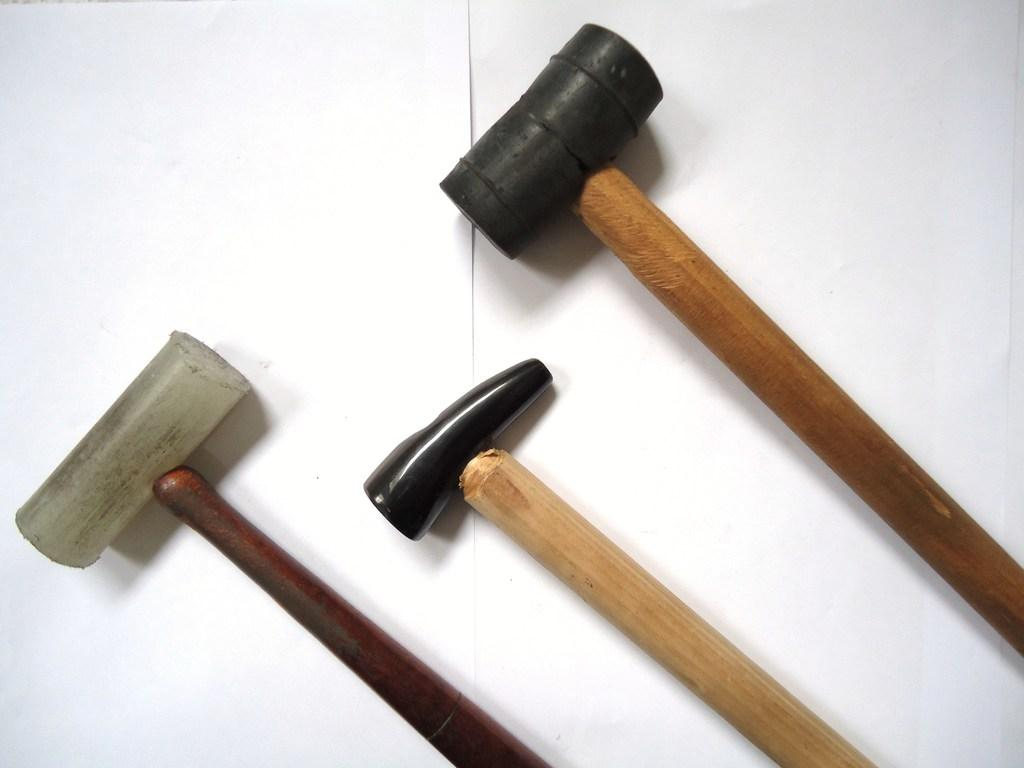How many hammers are visible in the image? There are three hammers in the image. What is the color of the surface on which the hammers are placed? The hammers are on a white surface. How many volleyballs can be seen in the image? There are no volleyballs present in the image. What is the value of the dime on the white surface? There is no dime present in the image. 